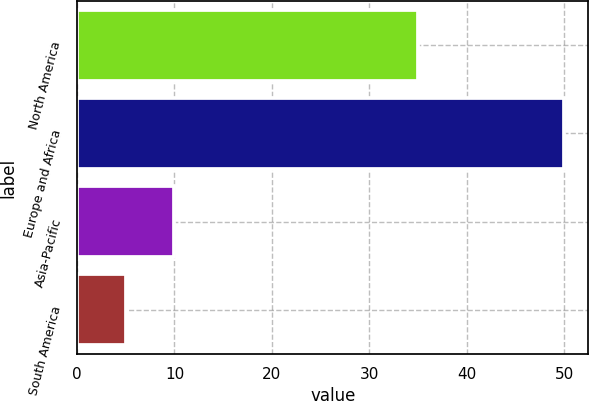Convert chart. <chart><loc_0><loc_0><loc_500><loc_500><bar_chart><fcel>North America<fcel>Europe and Africa<fcel>Asia-Pacific<fcel>South America<nl><fcel>35<fcel>50<fcel>10<fcel>5<nl></chart> 